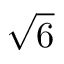Convert formula to latex. <formula><loc_0><loc_0><loc_500><loc_500>\sqrt { 6 }</formula> 